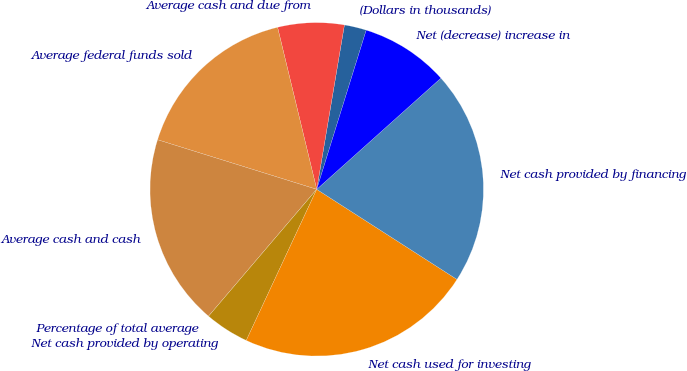Convert chart to OTSL. <chart><loc_0><loc_0><loc_500><loc_500><pie_chart><fcel>(Dollars in thousands)<fcel>Average cash and due from<fcel>Average federal funds sold<fcel>Average cash and cash<fcel>Percentage of total average<fcel>Net cash provided by operating<fcel>Net cash used for investing<fcel>Net cash provided by financing<fcel>Net (decrease) increase in<nl><fcel>2.14%<fcel>6.43%<fcel>16.42%<fcel>18.57%<fcel>0.0%<fcel>4.29%<fcel>22.86%<fcel>20.71%<fcel>8.58%<nl></chart> 